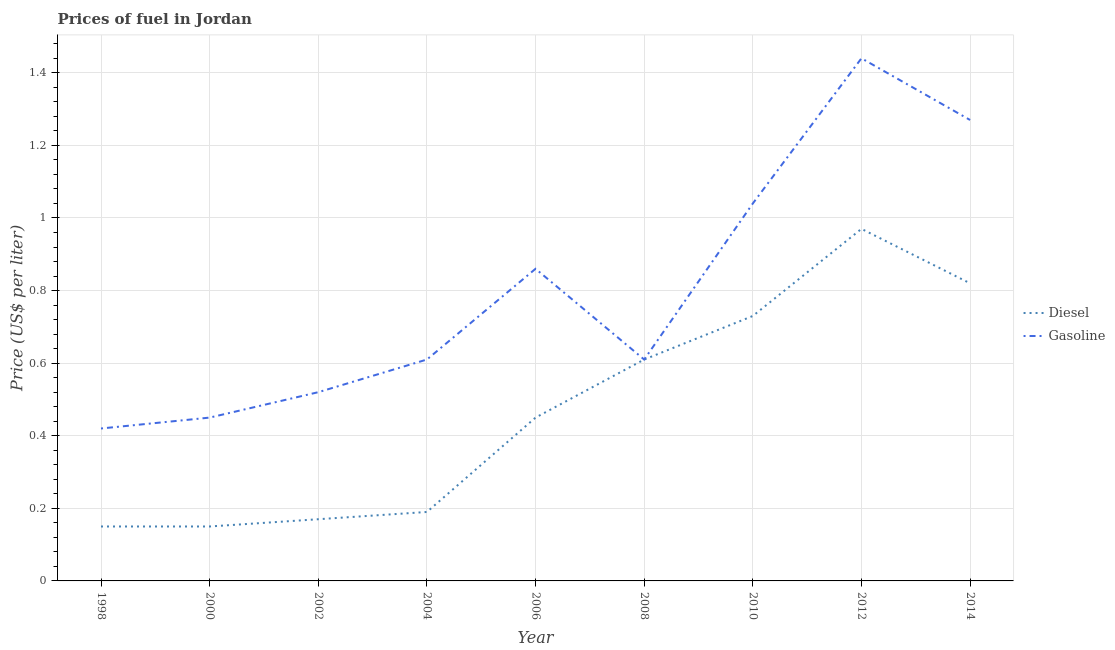What is the gasoline price in 2008?
Ensure brevity in your answer.  0.61. Across all years, what is the minimum gasoline price?
Ensure brevity in your answer.  0.42. In which year was the gasoline price minimum?
Keep it short and to the point. 1998. What is the total diesel price in the graph?
Offer a terse response. 4.24. What is the difference between the gasoline price in 1998 and that in 2014?
Make the answer very short. -0.85. What is the difference between the diesel price in 2002 and the gasoline price in 1998?
Your response must be concise. -0.25. What is the average diesel price per year?
Provide a short and direct response. 0.47. In the year 2000, what is the difference between the diesel price and gasoline price?
Offer a very short reply. -0.3. What is the ratio of the diesel price in 1998 to that in 2000?
Offer a very short reply. 1. Is the difference between the diesel price in 2006 and 2012 greater than the difference between the gasoline price in 2006 and 2012?
Make the answer very short. Yes. What is the difference between the highest and the second highest diesel price?
Your response must be concise. 0.15. What is the difference between the highest and the lowest diesel price?
Keep it short and to the point. 0.82. In how many years, is the diesel price greater than the average diesel price taken over all years?
Your answer should be very brief. 4. Is the sum of the gasoline price in 2000 and 2008 greater than the maximum diesel price across all years?
Give a very brief answer. Yes. Does the gasoline price monotonically increase over the years?
Offer a terse response. No. How many lines are there?
Ensure brevity in your answer.  2. How many years are there in the graph?
Offer a very short reply. 9. What is the difference between two consecutive major ticks on the Y-axis?
Give a very brief answer. 0.2. Are the values on the major ticks of Y-axis written in scientific E-notation?
Provide a short and direct response. No. Does the graph contain any zero values?
Your answer should be very brief. No. How many legend labels are there?
Offer a terse response. 2. How are the legend labels stacked?
Provide a short and direct response. Vertical. What is the title of the graph?
Provide a short and direct response. Prices of fuel in Jordan. Does "Commercial service imports" appear as one of the legend labels in the graph?
Provide a succinct answer. No. What is the label or title of the X-axis?
Provide a succinct answer. Year. What is the label or title of the Y-axis?
Keep it short and to the point. Price (US$ per liter). What is the Price (US$ per liter) in Gasoline in 1998?
Your response must be concise. 0.42. What is the Price (US$ per liter) in Gasoline in 2000?
Your answer should be very brief. 0.45. What is the Price (US$ per liter) of Diesel in 2002?
Offer a very short reply. 0.17. What is the Price (US$ per liter) in Gasoline in 2002?
Your answer should be very brief. 0.52. What is the Price (US$ per liter) in Diesel in 2004?
Your answer should be very brief. 0.19. What is the Price (US$ per liter) in Gasoline in 2004?
Offer a very short reply. 0.61. What is the Price (US$ per liter) in Diesel in 2006?
Your answer should be compact. 0.45. What is the Price (US$ per liter) in Gasoline in 2006?
Keep it short and to the point. 0.86. What is the Price (US$ per liter) of Diesel in 2008?
Provide a short and direct response. 0.61. What is the Price (US$ per liter) in Gasoline in 2008?
Provide a short and direct response. 0.61. What is the Price (US$ per liter) in Diesel in 2010?
Offer a terse response. 0.73. What is the Price (US$ per liter) in Diesel in 2012?
Ensure brevity in your answer.  0.97. What is the Price (US$ per liter) of Gasoline in 2012?
Ensure brevity in your answer.  1.44. What is the Price (US$ per liter) of Diesel in 2014?
Make the answer very short. 0.82. What is the Price (US$ per liter) of Gasoline in 2014?
Ensure brevity in your answer.  1.27. Across all years, what is the maximum Price (US$ per liter) in Diesel?
Make the answer very short. 0.97. Across all years, what is the maximum Price (US$ per liter) of Gasoline?
Give a very brief answer. 1.44. Across all years, what is the minimum Price (US$ per liter) in Diesel?
Your response must be concise. 0.15. Across all years, what is the minimum Price (US$ per liter) in Gasoline?
Ensure brevity in your answer.  0.42. What is the total Price (US$ per liter) in Diesel in the graph?
Provide a succinct answer. 4.24. What is the total Price (US$ per liter) of Gasoline in the graph?
Make the answer very short. 7.22. What is the difference between the Price (US$ per liter) of Gasoline in 1998 and that in 2000?
Your response must be concise. -0.03. What is the difference between the Price (US$ per liter) of Diesel in 1998 and that in 2002?
Your response must be concise. -0.02. What is the difference between the Price (US$ per liter) of Diesel in 1998 and that in 2004?
Ensure brevity in your answer.  -0.04. What is the difference between the Price (US$ per liter) of Gasoline in 1998 and that in 2004?
Give a very brief answer. -0.19. What is the difference between the Price (US$ per liter) of Diesel in 1998 and that in 2006?
Provide a succinct answer. -0.3. What is the difference between the Price (US$ per liter) in Gasoline in 1998 and that in 2006?
Your response must be concise. -0.44. What is the difference between the Price (US$ per liter) of Diesel in 1998 and that in 2008?
Your answer should be compact. -0.46. What is the difference between the Price (US$ per liter) in Gasoline in 1998 and that in 2008?
Provide a short and direct response. -0.19. What is the difference between the Price (US$ per liter) of Diesel in 1998 and that in 2010?
Keep it short and to the point. -0.58. What is the difference between the Price (US$ per liter) of Gasoline in 1998 and that in 2010?
Your response must be concise. -0.62. What is the difference between the Price (US$ per liter) of Diesel in 1998 and that in 2012?
Give a very brief answer. -0.82. What is the difference between the Price (US$ per liter) in Gasoline in 1998 and that in 2012?
Provide a succinct answer. -1.02. What is the difference between the Price (US$ per liter) of Diesel in 1998 and that in 2014?
Your answer should be compact. -0.67. What is the difference between the Price (US$ per liter) of Gasoline in 1998 and that in 2014?
Keep it short and to the point. -0.85. What is the difference between the Price (US$ per liter) in Diesel in 2000 and that in 2002?
Provide a short and direct response. -0.02. What is the difference between the Price (US$ per liter) of Gasoline in 2000 and that in 2002?
Make the answer very short. -0.07. What is the difference between the Price (US$ per liter) in Diesel in 2000 and that in 2004?
Offer a very short reply. -0.04. What is the difference between the Price (US$ per liter) in Gasoline in 2000 and that in 2004?
Make the answer very short. -0.16. What is the difference between the Price (US$ per liter) of Diesel in 2000 and that in 2006?
Provide a short and direct response. -0.3. What is the difference between the Price (US$ per liter) in Gasoline in 2000 and that in 2006?
Your answer should be very brief. -0.41. What is the difference between the Price (US$ per liter) in Diesel in 2000 and that in 2008?
Provide a short and direct response. -0.46. What is the difference between the Price (US$ per liter) of Gasoline in 2000 and that in 2008?
Give a very brief answer. -0.16. What is the difference between the Price (US$ per liter) of Diesel in 2000 and that in 2010?
Your response must be concise. -0.58. What is the difference between the Price (US$ per liter) in Gasoline in 2000 and that in 2010?
Offer a very short reply. -0.59. What is the difference between the Price (US$ per liter) in Diesel in 2000 and that in 2012?
Give a very brief answer. -0.82. What is the difference between the Price (US$ per liter) in Gasoline in 2000 and that in 2012?
Your answer should be very brief. -0.99. What is the difference between the Price (US$ per liter) in Diesel in 2000 and that in 2014?
Offer a terse response. -0.67. What is the difference between the Price (US$ per liter) of Gasoline in 2000 and that in 2014?
Keep it short and to the point. -0.82. What is the difference between the Price (US$ per liter) in Diesel in 2002 and that in 2004?
Keep it short and to the point. -0.02. What is the difference between the Price (US$ per liter) of Gasoline in 2002 and that in 2004?
Offer a terse response. -0.09. What is the difference between the Price (US$ per liter) of Diesel in 2002 and that in 2006?
Give a very brief answer. -0.28. What is the difference between the Price (US$ per liter) of Gasoline in 2002 and that in 2006?
Your answer should be compact. -0.34. What is the difference between the Price (US$ per liter) of Diesel in 2002 and that in 2008?
Your answer should be compact. -0.44. What is the difference between the Price (US$ per liter) of Gasoline in 2002 and that in 2008?
Offer a terse response. -0.09. What is the difference between the Price (US$ per liter) of Diesel in 2002 and that in 2010?
Make the answer very short. -0.56. What is the difference between the Price (US$ per liter) of Gasoline in 2002 and that in 2010?
Keep it short and to the point. -0.52. What is the difference between the Price (US$ per liter) of Diesel in 2002 and that in 2012?
Your answer should be compact. -0.8. What is the difference between the Price (US$ per liter) in Gasoline in 2002 and that in 2012?
Provide a short and direct response. -0.92. What is the difference between the Price (US$ per liter) of Diesel in 2002 and that in 2014?
Provide a succinct answer. -0.65. What is the difference between the Price (US$ per liter) of Gasoline in 2002 and that in 2014?
Give a very brief answer. -0.75. What is the difference between the Price (US$ per liter) of Diesel in 2004 and that in 2006?
Make the answer very short. -0.26. What is the difference between the Price (US$ per liter) in Gasoline in 2004 and that in 2006?
Keep it short and to the point. -0.25. What is the difference between the Price (US$ per liter) in Diesel in 2004 and that in 2008?
Ensure brevity in your answer.  -0.42. What is the difference between the Price (US$ per liter) of Diesel in 2004 and that in 2010?
Your response must be concise. -0.54. What is the difference between the Price (US$ per liter) of Gasoline in 2004 and that in 2010?
Your answer should be very brief. -0.43. What is the difference between the Price (US$ per liter) in Diesel in 2004 and that in 2012?
Your answer should be very brief. -0.78. What is the difference between the Price (US$ per liter) of Gasoline in 2004 and that in 2012?
Provide a short and direct response. -0.83. What is the difference between the Price (US$ per liter) in Diesel in 2004 and that in 2014?
Offer a terse response. -0.63. What is the difference between the Price (US$ per liter) in Gasoline in 2004 and that in 2014?
Ensure brevity in your answer.  -0.66. What is the difference between the Price (US$ per liter) of Diesel in 2006 and that in 2008?
Provide a short and direct response. -0.16. What is the difference between the Price (US$ per liter) of Diesel in 2006 and that in 2010?
Offer a terse response. -0.28. What is the difference between the Price (US$ per liter) of Gasoline in 2006 and that in 2010?
Your answer should be compact. -0.18. What is the difference between the Price (US$ per liter) in Diesel in 2006 and that in 2012?
Keep it short and to the point. -0.52. What is the difference between the Price (US$ per liter) of Gasoline in 2006 and that in 2012?
Your response must be concise. -0.58. What is the difference between the Price (US$ per liter) in Diesel in 2006 and that in 2014?
Give a very brief answer. -0.37. What is the difference between the Price (US$ per liter) in Gasoline in 2006 and that in 2014?
Ensure brevity in your answer.  -0.41. What is the difference between the Price (US$ per liter) of Diesel in 2008 and that in 2010?
Your answer should be very brief. -0.12. What is the difference between the Price (US$ per liter) in Gasoline in 2008 and that in 2010?
Ensure brevity in your answer.  -0.43. What is the difference between the Price (US$ per liter) of Diesel in 2008 and that in 2012?
Provide a succinct answer. -0.36. What is the difference between the Price (US$ per liter) in Gasoline in 2008 and that in 2012?
Provide a short and direct response. -0.83. What is the difference between the Price (US$ per liter) of Diesel in 2008 and that in 2014?
Provide a succinct answer. -0.21. What is the difference between the Price (US$ per liter) of Gasoline in 2008 and that in 2014?
Your answer should be compact. -0.66. What is the difference between the Price (US$ per liter) of Diesel in 2010 and that in 2012?
Offer a very short reply. -0.24. What is the difference between the Price (US$ per liter) in Gasoline in 2010 and that in 2012?
Your response must be concise. -0.4. What is the difference between the Price (US$ per liter) of Diesel in 2010 and that in 2014?
Keep it short and to the point. -0.09. What is the difference between the Price (US$ per liter) in Gasoline in 2010 and that in 2014?
Make the answer very short. -0.23. What is the difference between the Price (US$ per liter) of Diesel in 2012 and that in 2014?
Your response must be concise. 0.15. What is the difference between the Price (US$ per liter) of Gasoline in 2012 and that in 2014?
Give a very brief answer. 0.17. What is the difference between the Price (US$ per liter) in Diesel in 1998 and the Price (US$ per liter) in Gasoline in 2000?
Your answer should be compact. -0.3. What is the difference between the Price (US$ per liter) in Diesel in 1998 and the Price (US$ per liter) in Gasoline in 2002?
Keep it short and to the point. -0.37. What is the difference between the Price (US$ per liter) in Diesel in 1998 and the Price (US$ per liter) in Gasoline in 2004?
Keep it short and to the point. -0.46. What is the difference between the Price (US$ per liter) of Diesel in 1998 and the Price (US$ per liter) of Gasoline in 2006?
Provide a succinct answer. -0.71. What is the difference between the Price (US$ per liter) in Diesel in 1998 and the Price (US$ per liter) in Gasoline in 2008?
Keep it short and to the point. -0.46. What is the difference between the Price (US$ per liter) in Diesel in 1998 and the Price (US$ per liter) in Gasoline in 2010?
Ensure brevity in your answer.  -0.89. What is the difference between the Price (US$ per liter) of Diesel in 1998 and the Price (US$ per liter) of Gasoline in 2012?
Provide a short and direct response. -1.29. What is the difference between the Price (US$ per liter) in Diesel in 1998 and the Price (US$ per liter) in Gasoline in 2014?
Provide a short and direct response. -1.12. What is the difference between the Price (US$ per liter) in Diesel in 2000 and the Price (US$ per liter) in Gasoline in 2002?
Ensure brevity in your answer.  -0.37. What is the difference between the Price (US$ per liter) of Diesel in 2000 and the Price (US$ per liter) of Gasoline in 2004?
Keep it short and to the point. -0.46. What is the difference between the Price (US$ per liter) of Diesel in 2000 and the Price (US$ per liter) of Gasoline in 2006?
Your answer should be compact. -0.71. What is the difference between the Price (US$ per liter) of Diesel in 2000 and the Price (US$ per liter) of Gasoline in 2008?
Your response must be concise. -0.46. What is the difference between the Price (US$ per liter) in Diesel in 2000 and the Price (US$ per liter) in Gasoline in 2010?
Provide a succinct answer. -0.89. What is the difference between the Price (US$ per liter) of Diesel in 2000 and the Price (US$ per liter) of Gasoline in 2012?
Keep it short and to the point. -1.29. What is the difference between the Price (US$ per liter) in Diesel in 2000 and the Price (US$ per liter) in Gasoline in 2014?
Your answer should be very brief. -1.12. What is the difference between the Price (US$ per liter) of Diesel in 2002 and the Price (US$ per liter) of Gasoline in 2004?
Your answer should be very brief. -0.44. What is the difference between the Price (US$ per liter) of Diesel in 2002 and the Price (US$ per liter) of Gasoline in 2006?
Your answer should be compact. -0.69. What is the difference between the Price (US$ per liter) of Diesel in 2002 and the Price (US$ per liter) of Gasoline in 2008?
Your answer should be compact. -0.44. What is the difference between the Price (US$ per liter) of Diesel in 2002 and the Price (US$ per liter) of Gasoline in 2010?
Offer a very short reply. -0.87. What is the difference between the Price (US$ per liter) in Diesel in 2002 and the Price (US$ per liter) in Gasoline in 2012?
Provide a short and direct response. -1.27. What is the difference between the Price (US$ per liter) of Diesel in 2002 and the Price (US$ per liter) of Gasoline in 2014?
Provide a succinct answer. -1.1. What is the difference between the Price (US$ per liter) of Diesel in 2004 and the Price (US$ per liter) of Gasoline in 2006?
Provide a short and direct response. -0.67. What is the difference between the Price (US$ per liter) of Diesel in 2004 and the Price (US$ per liter) of Gasoline in 2008?
Give a very brief answer. -0.42. What is the difference between the Price (US$ per liter) in Diesel in 2004 and the Price (US$ per liter) in Gasoline in 2010?
Provide a succinct answer. -0.85. What is the difference between the Price (US$ per liter) in Diesel in 2004 and the Price (US$ per liter) in Gasoline in 2012?
Give a very brief answer. -1.25. What is the difference between the Price (US$ per liter) in Diesel in 2004 and the Price (US$ per liter) in Gasoline in 2014?
Your answer should be compact. -1.08. What is the difference between the Price (US$ per liter) in Diesel in 2006 and the Price (US$ per liter) in Gasoline in 2008?
Make the answer very short. -0.16. What is the difference between the Price (US$ per liter) in Diesel in 2006 and the Price (US$ per liter) in Gasoline in 2010?
Offer a very short reply. -0.59. What is the difference between the Price (US$ per liter) in Diesel in 2006 and the Price (US$ per liter) in Gasoline in 2012?
Your answer should be compact. -0.99. What is the difference between the Price (US$ per liter) of Diesel in 2006 and the Price (US$ per liter) of Gasoline in 2014?
Provide a short and direct response. -0.82. What is the difference between the Price (US$ per liter) of Diesel in 2008 and the Price (US$ per liter) of Gasoline in 2010?
Offer a terse response. -0.43. What is the difference between the Price (US$ per liter) in Diesel in 2008 and the Price (US$ per liter) in Gasoline in 2012?
Your answer should be very brief. -0.83. What is the difference between the Price (US$ per liter) of Diesel in 2008 and the Price (US$ per liter) of Gasoline in 2014?
Your response must be concise. -0.66. What is the difference between the Price (US$ per liter) of Diesel in 2010 and the Price (US$ per liter) of Gasoline in 2012?
Your answer should be very brief. -0.71. What is the difference between the Price (US$ per liter) of Diesel in 2010 and the Price (US$ per liter) of Gasoline in 2014?
Your response must be concise. -0.54. What is the difference between the Price (US$ per liter) of Diesel in 2012 and the Price (US$ per liter) of Gasoline in 2014?
Offer a terse response. -0.3. What is the average Price (US$ per liter) of Diesel per year?
Your answer should be compact. 0.47. What is the average Price (US$ per liter) of Gasoline per year?
Your answer should be very brief. 0.8. In the year 1998, what is the difference between the Price (US$ per liter) in Diesel and Price (US$ per liter) in Gasoline?
Provide a succinct answer. -0.27. In the year 2000, what is the difference between the Price (US$ per liter) of Diesel and Price (US$ per liter) of Gasoline?
Give a very brief answer. -0.3. In the year 2002, what is the difference between the Price (US$ per liter) of Diesel and Price (US$ per liter) of Gasoline?
Your response must be concise. -0.35. In the year 2004, what is the difference between the Price (US$ per liter) in Diesel and Price (US$ per liter) in Gasoline?
Your response must be concise. -0.42. In the year 2006, what is the difference between the Price (US$ per liter) of Diesel and Price (US$ per liter) of Gasoline?
Give a very brief answer. -0.41. In the year 2010, what is the difference between the Price (US$ per liter) of Diesel and Price (US$ per liter) of Gasoline?
Make the answer very short. -0.31. In the year 2012, what is the difference between the Price (US$ per liter) in Diesel and Price (US$ per liter) in Gasoline?
Ensure brevity in your answer.  -0.47. In the year 2014, what is the difference between the Price (US$ per liter) of Diesel and Price (US$ per liter) of Gasoline?
Your answer should be very brief. -0.45. What is the ratio of the Price (US$ per liter) in Gasoline in 1998 to that in 2000?
Give a very brief answer. 0.93. What is the ratio of the Price (US$ per liter) in Diesel in 1998 to that in 2002?
Make the answer very short. 0.88. What is the ratio of the Price (US$ per liter) of Gasoline in 1998 to that in 2002?
Offer a terse response. 0.81. What is the ratio of the Price (US$ per liter) of Diesel in 1998 to that in 2004?
Your response must be concise. 0.79. What is the ratio of the Price (US$ per liter) in Gasoline in 1998 to that in 2004?
Your answer should be compact. 0.69. What is the ratio of the Price (US$ per liter) in Diesel in 1998 to that in 2006?
Make the answer very short. 0.33. What is the ratio of the Price (US$ per liter) in Gasoline in 1998 to that in 2006?
Your answer should be very brief. 0.49. What is the ratio of the Price (US$ per liter) of Diesel in 1998 to that in 2008?
Your answer should be very brief. 0.25. What is the ratio of the Price (US$ per liter) of Gasoline in 1998 to that in 2008?
Offer a very short reply. 0.69. What is the ratio of the Price (US$ per liter) in Diesel in 1998 to that in 2010?
Keep it short and to the point. 0.21. What is the ratio of the Price (US$ per liter) in Gasoline in 1998 to that in 2010?
Give a very brief answer. 0.4. What is the ratio of the Price (US$ per liter) in Diesel in 1998 to that in 2012?
Your answer should be very brief. 0.15. What is the ratio of the Price (US$ per liter) of Gasoline in 1998 to that in 2012?
Make the answer very short. 0.29. What is the ratio of the Price (US$ per liter) in Diesel in 1998 to that in 2014?
Offer a very short reply. 0.18. What is the ratio of the Price (US$ per liter) in Gasoline in 1998 to that in 2014?
Offer a very short reply. 0.33. What is the ratio of the Price (US$ per liter) in Diesel in 2000 to that in 2002?
Offer a terse response. 0.88. What is the ratio of the Price (US$ per liter) of Gasoline in 2000 to that in 2002?
Your response must be concise. 0.87. What is the ratio of the Price (US$ per liter) in Diesel in 2000 to that in 2004?
Make the answer very short. 0.79. What is the ratio of the Price (US$ per liter) in Gasoline in 2000 to that in 2004?
Give a very brief answer. 0.74. What is the ratio of the Price (US$ per liter) in Diesel in 2000 to that in 2006?
Offer a very short reply. 0.33. What is the ratio of the Price (US$ per liter) of Gasoline in 2000 to that in 2006?
Your response must be concise. 0.52. What is the ratio of the Price (US$ per liter) in Diesel in 2000 to that in 2008?
Give a very brief answer. 0.25. What is the ratio of the Price (US$ per liter) of Gasoline in 2000 to that in 2008?
Your response must be concise. 0.74. What is the ratio of the Price (US$ per liter) of Diesel in 2000 to that in 2010?
Give a very brief answer. 0.21. What is the ratio of the Price (US$ per liter) in Gasoline in 2000 to that in 2010?
Your response must be concise. 0.43. What is the ratio of the Price (US$ per liter) in Diesel in 2000 to that in 2012?
Give a very brief answer. 0.15. What is the ratio of the Price (US$ per liter) of Gasoline in 2000 to that in 2012?
Offer a very short reply. 0.31. What is the ratio of the Price (US$ per liter) of Diesel in 2000 to that in 2014?
Keep it short and to the point. 0.18. What is the ratio of the Price (US$ per liter) of Gasoline in 2000 to that in 2014?
Keep it short and to the point. 0.35. What is the ratio of the Price (US$ per liter) in Diesel in 2002 to that in 2004?
Make the answer very short. 0.89. What is the ratio of the Price (US$ per liter) in Gasoline in 2002 to that in 2004?
Provide a short and direct response. 0.85. What is the ratio of the Price (US$ per liter) of Diesel in 2002 to that in 2006?
Offer a very short reply. 0.38. What is the ratio of the Price (US$ per liter) in Gasoline in 2002 to that in 2006?
Offer a very short reply. 0.6. What is the ratio of the Price (US$ per liter) in Diesel in 2002 to that in 2008?
Provide a short and direct response. 0.28. What is the ratio of the Price (US$ per liter) in Gasoline in 2002 to that in 2008?
Offer a terse response. 0.85. What is the ratio of the Price (US$ per liter) in Diesel in 2002 to that in 2010?
Provide a succinct answer. 0.23. What is the ratio of the Price (US$ per liter) in Gasoline in 2002 to that in 2010?
Your answer should be compact. 0.5. What is the ratio of the Price (US$ per liter) in Diesel in 2002 to that in 2012?
Give a very brief answer. 0.18. What is the ratio of the Price (US$ per liter) of Gasoline in 2002 to that in 2012?
Your answer should be compact. 0.36. What is the ratio of the Price (US$ per liter) in Diesel in 2002 to that in 2014?
Your answer should be compact. 0.21. What is the ratio of the Price (US$ per liter) in Gasoline in 2002 to that in 2014?
Offer a very short reply. 0.41. What is the ratio of the Price (US$ per liter) in Diesel in 2004 to that in 2006?
Offer a very short reply. 0.42. What is the ratio of the Price (US$ per liter) of Gasoline in 2004 to that in 2006?
Your answer should be very brief. 0.71. What is the ratio of the Price (US$ per liter) of Diesel in 2004 to that in 2008?
Offer a terse response. 0.31. What is the ratio of the Price (US$ per liter) in Diesel in 2004 to that in 2010?
Your answer should be very brief. 0.26. What is the ratio of the Price (US$ per liter) in Gasoline in 2004 to that in 2010?
Provide a short and direct response. 0.59. What is the ratio of the Price (US$ per liter) in Diesel in 2004 to that in 2012?
Keep it short and to the point. 0.2. What is the ratio of the Price (US$ per liter) in Gasoline in 2004 to that in 2012?
Your answer should be very brief. 0.42. What is the ratio of the Price (US$ per liter) of Diesel in 2004 to that in 2014?
Give a very brief answer. 0.23. What is the ratio of the Price (US$ per liter) in Gasoline in 2004 to that in 2014?
Your answer should be compact. 0.48. What is the ratio of the Price (US$ per liter) in Diesel in 2006 to that in 2008?
Offer a very short reply. 0.74. What is the ratio of the Price (US$ per liter) of Gasoline in 2006 to that in 2008?
Ensure brevity in your answer.  1.41. What is the ratio of the Price (US$ per liter) of Diesel in 2006 to that in 2010?
Offer a terse response. 0.62. What is the ratio of the Price (US$ per liter) in Gasoline in 2006 to that in 2010?
Keep it short and to the point. 0.83. What is the ratio of the Price (US$ per liter) of Diesel in 2006 to that in 2012?
Make the answer very short. 0.46. What is the ratio of the Price (US$ per liter) of Gasoline in 2006 to that in 2012?
Make the answer very short. 0.6. What is the ratio of the Price (US$ per liter) of Diesel in 2006 to that in 2014?
Offer a very short reply. 0.55. What is the ratio of the Price (US$ per liter) of Gasoline in 2006 to that in 2014?
Offer a very short reply. 0.68. What is the ratio of the Price (US$ per liter) of Diesel in 2008 to that in 2010?
Your answer should be compact. 0.84. What is the ratio of the Price (US$ per liter) in Gasoline in 2008 to that in 2010?
Your response must be concise. 0.59. What is the ratio of the Price (US$ per liter) in Diesel in 2008 to that in 2012?
Provide a succinct answer. 0.63. What is the ratio of the Price (US$ per liter) of Gasoline in 2008 to that in 2012?
Your answer should be compact. 0.42. What is the ratio of the Price (US$ per liter) of Diesel in 2008 to that in 2014?
Offer a very short reply. 0.74. What is the ratio of the Price (US$ per liter) of Gasoline in 2008 to that in 2014?
Offer a very short reply. 0.48. What is the ratio of the Price (US$ per liter) in Diesel in 2010 to that in 2012?
Provide a short and direct response. 0.75. What is the ratio of the Price (US$ per liter) in Gasoline in 2010 to that in 2012?
Provide a succinct answer. 0.72. What is the ratio of the Price (US$ per liter) of Diesel in 2010 to that in 2014?
Offer a terse response. 0.89. What is the ratio of the Price (US$ per liter) in Gasoline in 2010 to that in 2014?
Your response must be concise. 0.82. What is the ratio of the Price (US$ per liter) in Diesel in 2012 to that in 2014?
Your response must be concise. 1.18. What is the ratio of the Price (US$ per liter) in Gasoline in 2012 to that in 2014?
Offer a very short reply. 1.13. What is the difference between the highest and the second highest Price (US$ per liter) of Diesel?
Your response must be concise. 0.15. What is the difference between the highest and the second highest Price (US$ per liter) of Gasoline?
Make the answer very short. 0.17. What is the difference between the highest and the lowest Price (US$ per liter) in Diesel?
Your answer should be very brief. 0.82. What is the difference between the highest and the lowest Price (US$ per liter) in Gasoline?
Keep it short and to the point. 1.02. 